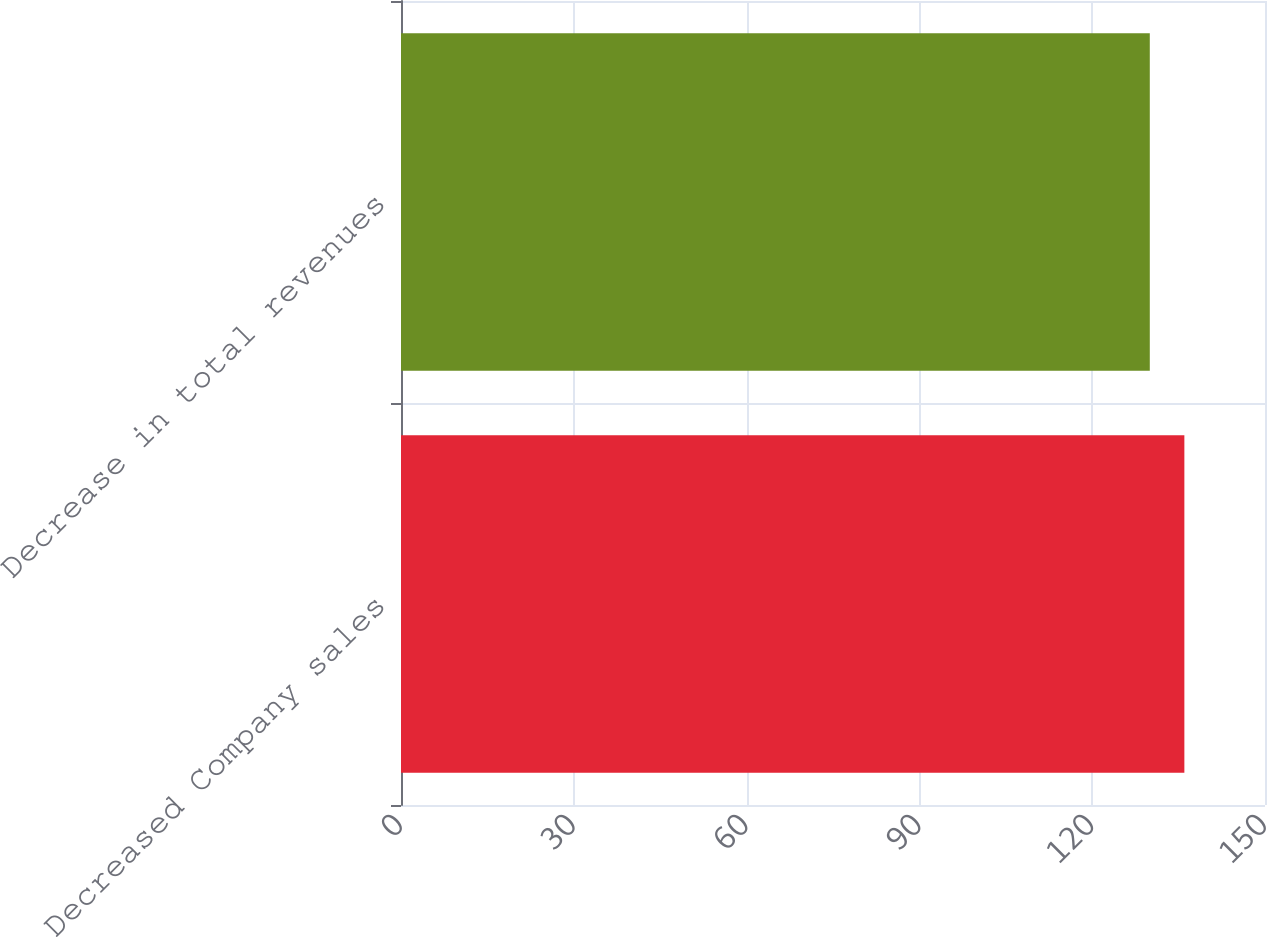<chart> <loc_0><loc_0><loc_500><loc_500><bar_chart><fcel>Decreased Company sales<fcel>Decrease in total revenues<nl><fcel>136<fcel>130<nl></chart> 